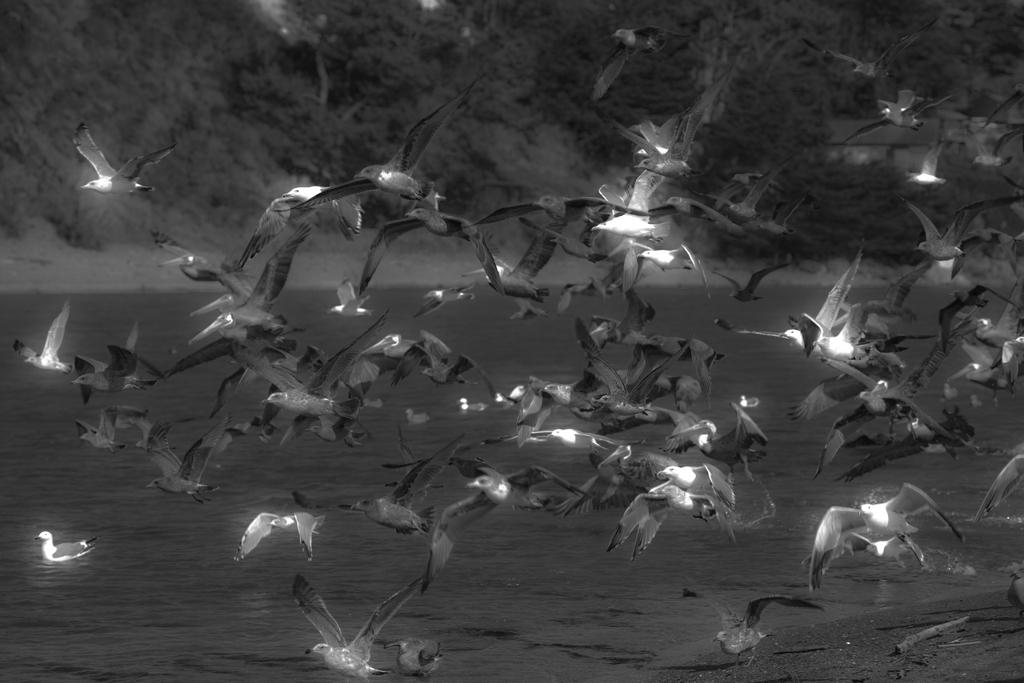What is the color scheme of the image? The image is black and white. What can be seen in the foreground of the image? There are birds flying in the air in the foreground. What is visible in the background of the image? There is a river in the background. What type of vegetation is present at the top of the image? There are many trees at the top of the image. What type of government is depicted in the image? There is no depiction of a government in the image; it features birds, a river, and trees. What type of frame surrounds the image? There is no frame visible in the image; it is a standalone photograph or illustration. 